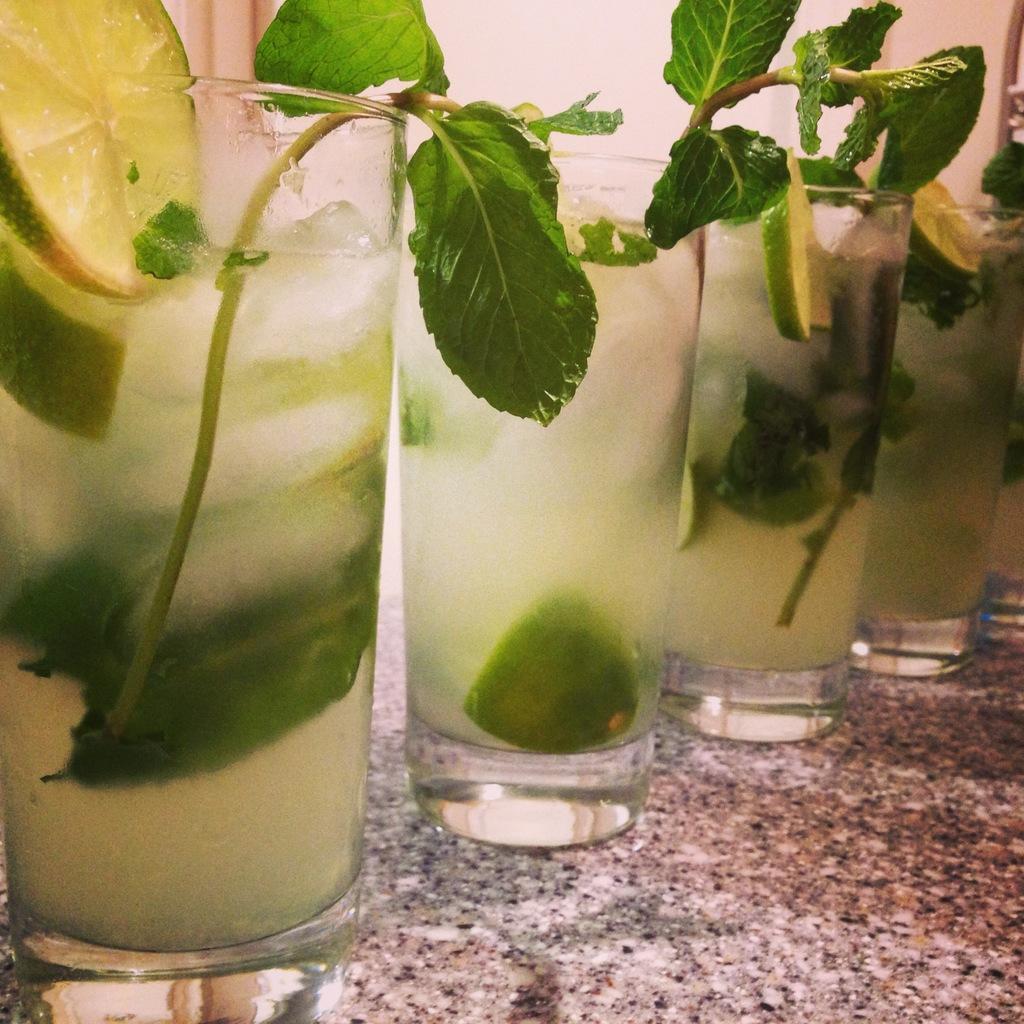In one or two sentences, can you explain what this image depicts? At the bottom of the image there is a table with five glasses of lime juice on it. There are a few lemon slices, ice cubes and mint leaves in the glasses. In the background there is a wall. 